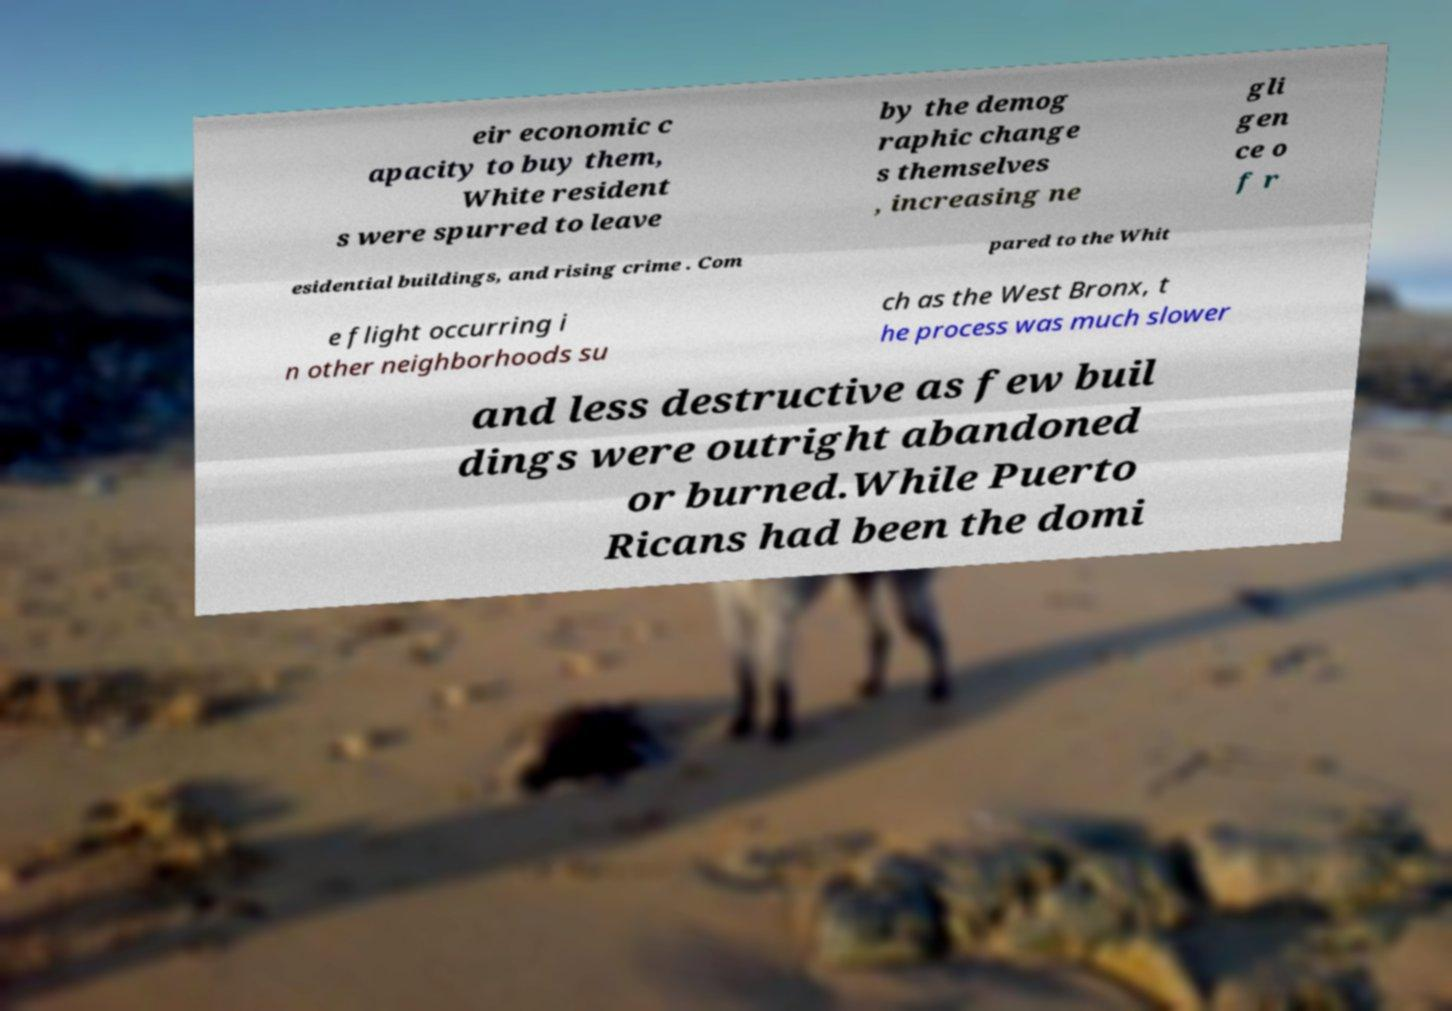I need the written content from this picture converted into text. Can you do that? eir economic c apacity to buy them, White resident s were spurred to leave by the demog raphic change s themselves , increasing ne gli gen ce o f r esidential buildings, and rising crime . Com pared to the Whit e flight occurring i n other neighborhoods su ch as the West Bronx, t he process was much slower and less destructive as few buil dings were outright abandoned or burned.While Puerto Ricans had been the domi 